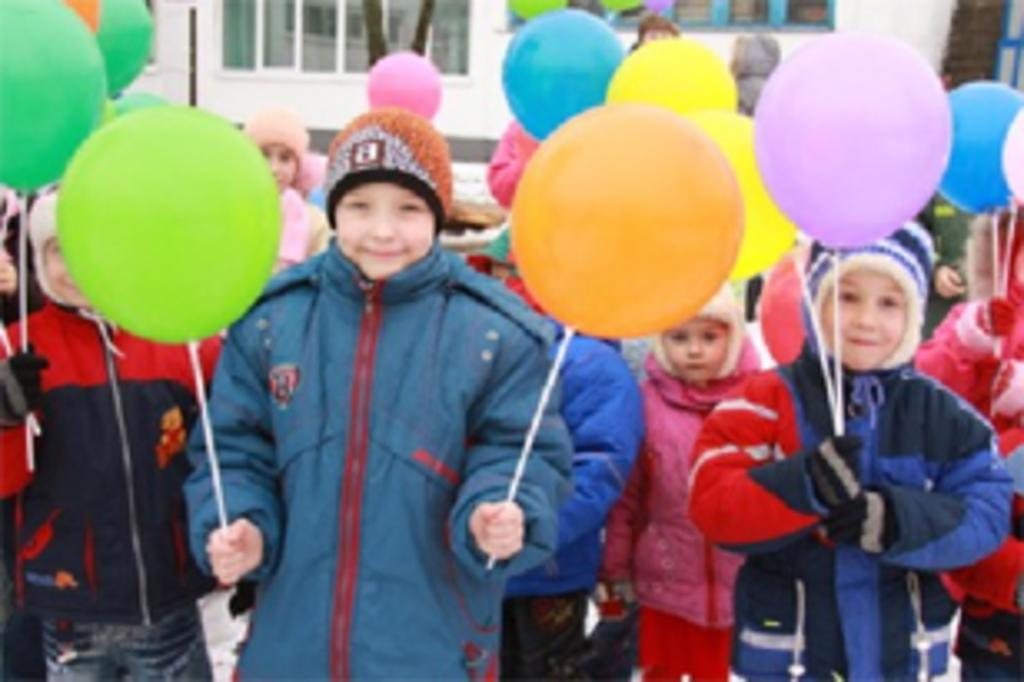What is the main subject of the image? The main subject of the image is a group of children. What are the children doing in the image? The children are standing and holding balloons in their hands. What are the children wearing in the image? The children are wearing caps and jackets. What can be seen in the background of the image? There are objects in the background of the image. How many spiders are crawling on the children's jackets in the image? There are no spiders present on the children's jackets in the image. Can you tell me which parent is accompanying the children in the image? There is no parent visible in the image; it only shows a group of children. 